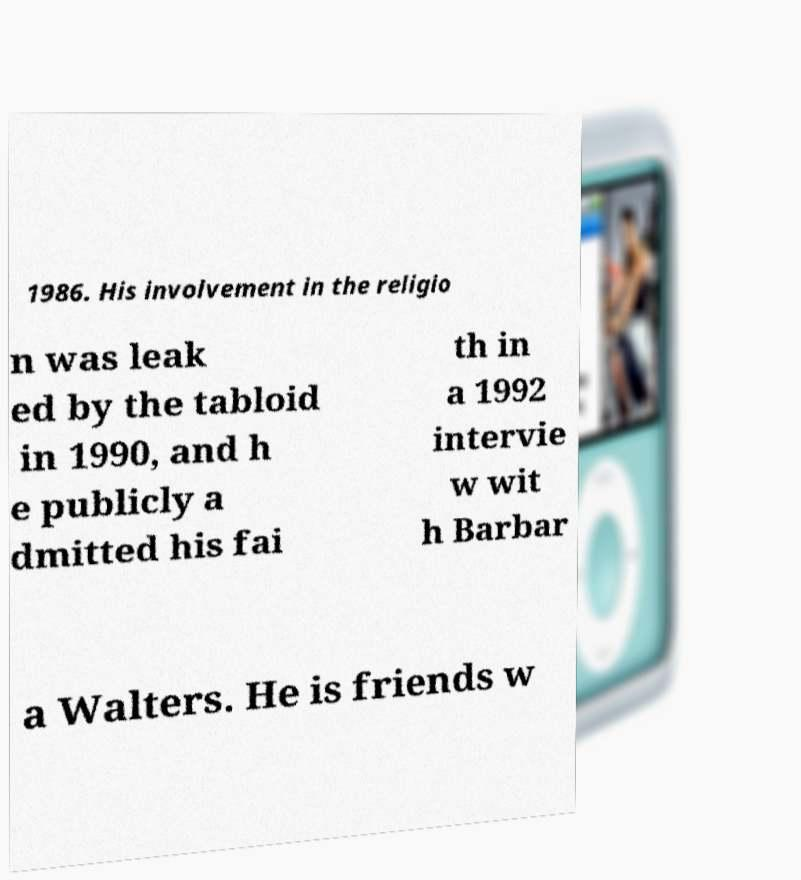Please read and relay the text visible in this image. What does it say? 1986. His involvement in the religio n was leak ed by the tabloid in 1990, and h e publicly a dmitted his fai th in a 1992 intervie w wit h Barbar a Walters. He is friends w 